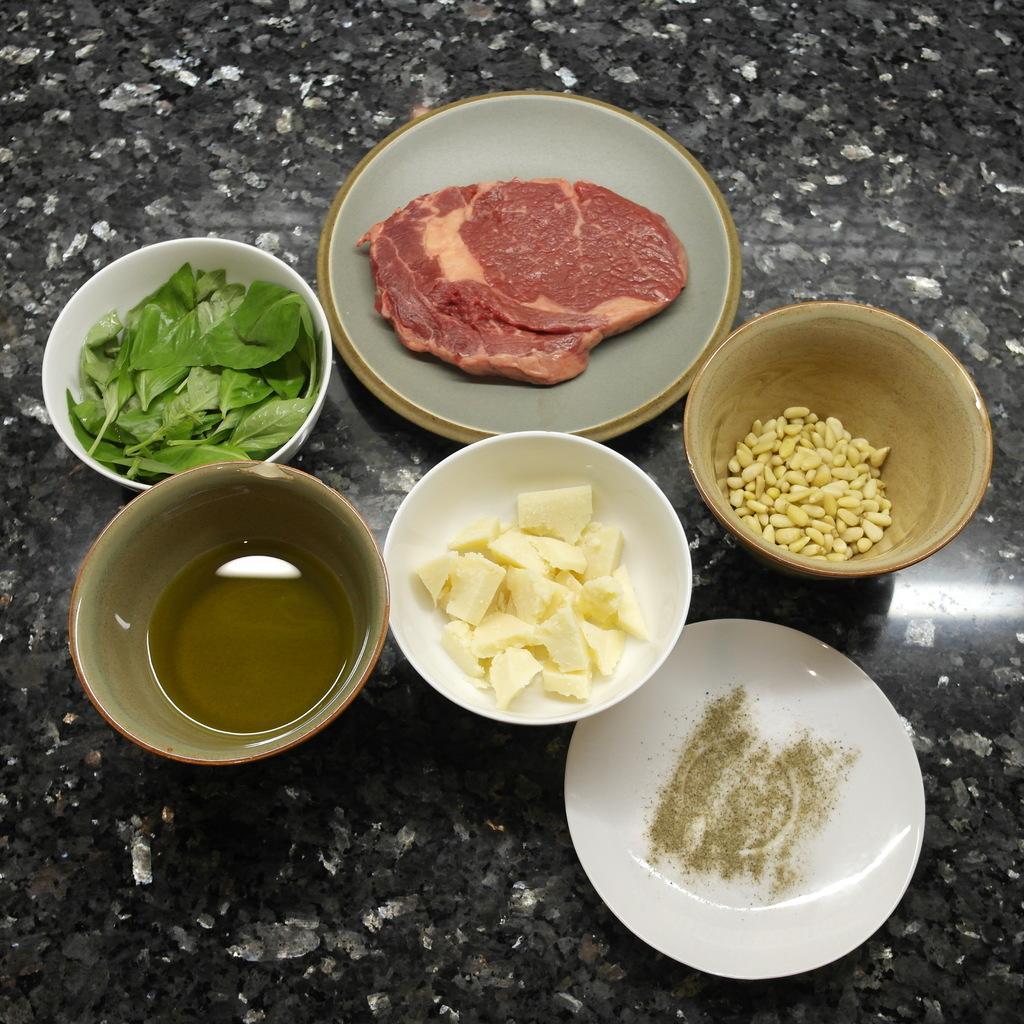Describe this image in one or two sentences. In this image I can see few food items in the bowls and these are on the black and white color surface. 